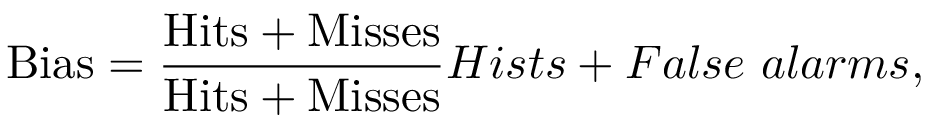<formula> <loc_0><loc_0><loc_500><loc_500>B i a s = \frac { H i t s + M i s s e s } { H i t s + M i s s e s } { H i s t s + F a l s e \ a l a r m s } ,</formula> 